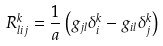<formula> <loc_0><loc_0><loc_500><loc_500>R ^ { k } _ { l i j } = \frac { 1 } { a } \left ( g _ { j l } \delta _ { i } ^ { k } - g _ { i l } \delta _ { j } ^ { k } \right )</formula> 